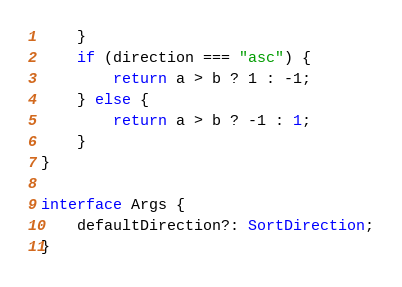<code> <loc_0><loc_0><loc_500><loc_500><_TypeScript_>    }
    if (direction === "asc") {
        return a > b ? 1 : -1;
    } else {
        return a > b ? -1 : 1;
    }
}

interface Args {
    defaultDirection?: SortDirection;
}
</code> 